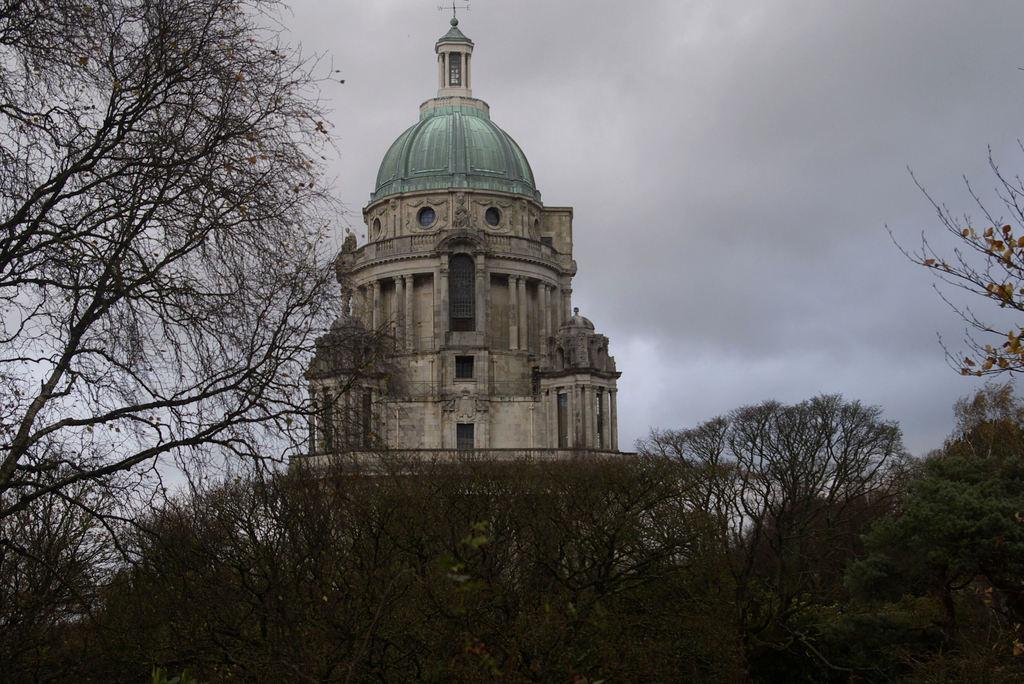In one or two sentences, can you explain what this image depicts? In this picture there is a building and there are trees. At the top there is sky and there are clouds and there is a direction pole on the top of the building. 